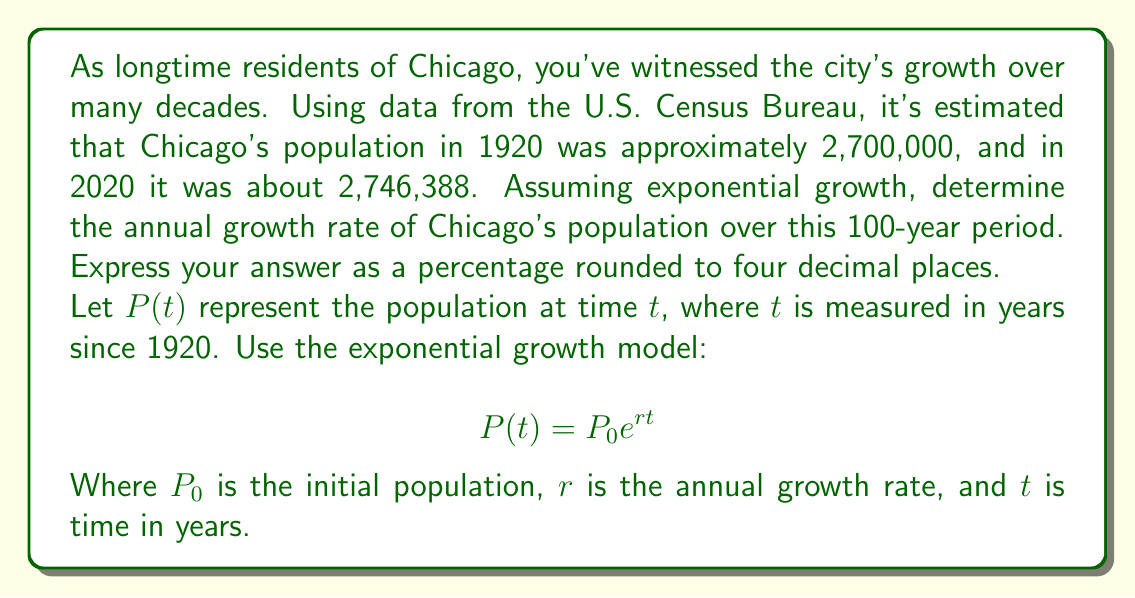What is the answer to this math problem? Let's approach this step-by-step:

1) We know that:
   $P_0 = 2,700,000$ (population in 1920)
   $P(100) = 2,746,388$ (population in 2020, 100 years later)

2) Using the exponential growth model:
   $$P(100) = P_0e^{r(100)}$$

3) Substituting the known values:
   $$2,746,388 = 2,700,000e^{100r}$$

4) Dividing both sides by 2,700,000:
   $$\frac{2,746,388}{2,700,000} = e^{100r}$$

5) Taking the natural logarithm of both sides:
   $$\ln(\frac{2,746,388}{2,700,000}) = 100r$$

6) Solving for $r$:
   $$r = \frac{\ln(\frac{2,746,388}{2,700,000})}{100}$$

7) Calculating:
   $$r = \frac{\ln(1.017181481)}{100} = 0.0001703$$

8) Converting to a percentage and rounding to four decimal places:
   $r = 0.01703\%$

This small positive growth rate reflects the fact that while Chicago's population has grown over the century, the growth has been very slow, with periods of decline offset by periods of more rapid growth.
Answer: The annual growth rate of Chicago's population from 1920 to 2020 is approximately $0.0170\%$. 